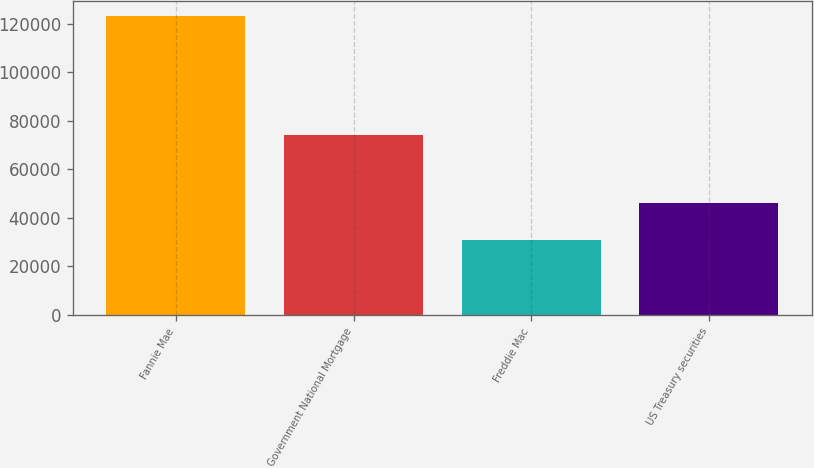Convert chart. <chart><loc_0><loc_0><loc_500><loc_500><bar_chart><fcel>Fannie Mae<fcel>Government National Mortgage<fcel>Freddie Mac<fcel>US Treasury securities<nl><fcel>123107<fcel>74305<fcel>30822<fcel>46081<nl></chart> 